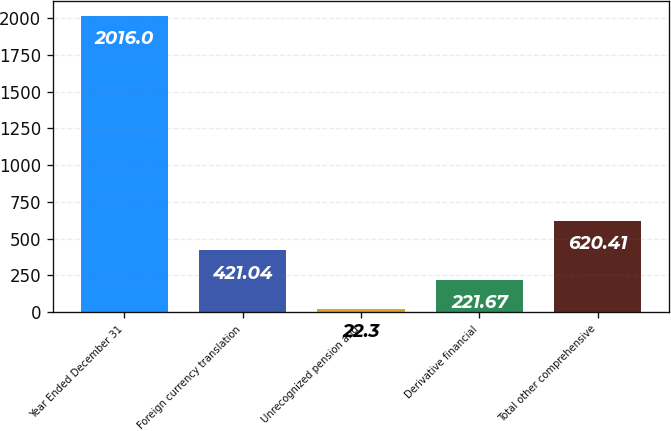Convert chart to OTSL. <chart><loc_0><loc_0><loc_500><loc_500><bar_chart><fcel>Year Ended December 31<fcel>Foreign currency translation<fcel>Unrecognized pension and<fcel>Derivative financial<fcel>Total other comprehensive<nl><fcel>2016<fcel>421.04<fcel>22.3<fcel>221.67<fcel>620.41<nl></chart> 